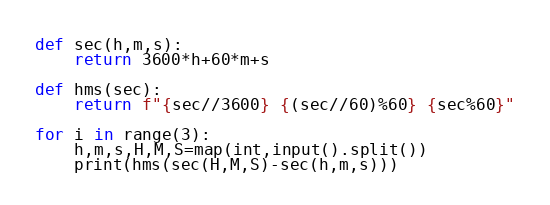Convert code to text. <code><loc_0><loc_0><loc_500><loc_500><_Python_>def sec(h,m,s):
	return 3600*h+60*m+s

def hms(sec):
	return f"{sec//3600} {(sec//60)%60} {sec%60}"

for i in range(3):
	h,m,s,H,M,S=map(int,input().split())
	print(hms(sec(H,M,S)-sec(h,m,s)))

</code> 